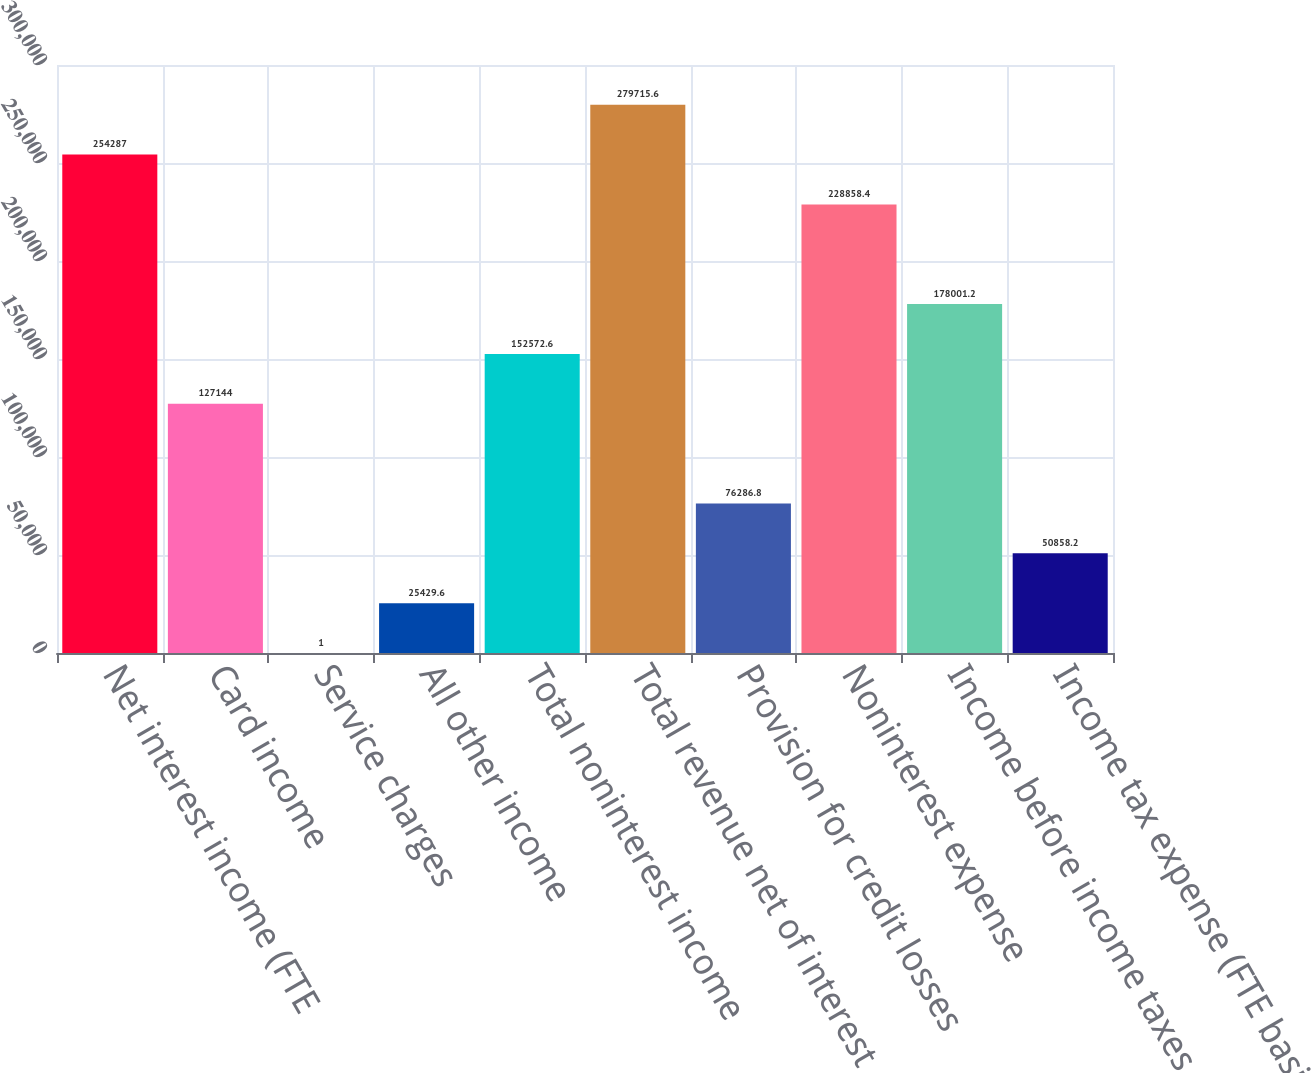Convert chart. <chart><loc_0><loc_0><loc_500><loc_500><bar_chart><fcel>Net interest income (FTE<fcel>Card income<fcel>Service charges<fcel>All other income<fcel>Total noninterest income<fcel>Total revenue net of interest<fcel>Provision for credit losses<fcel>Noninterest expense<fcel>Income before income taxes<fcel>Income tax expense (FTE basis)<nl><fcel>254287<fcel>127144<fcel>1<fcel>25429.6<fcel>152573<fcel>279716<fcel>76286.8<fcel>228858<fcel>178001<fcel>50858.2<nl></chart> 